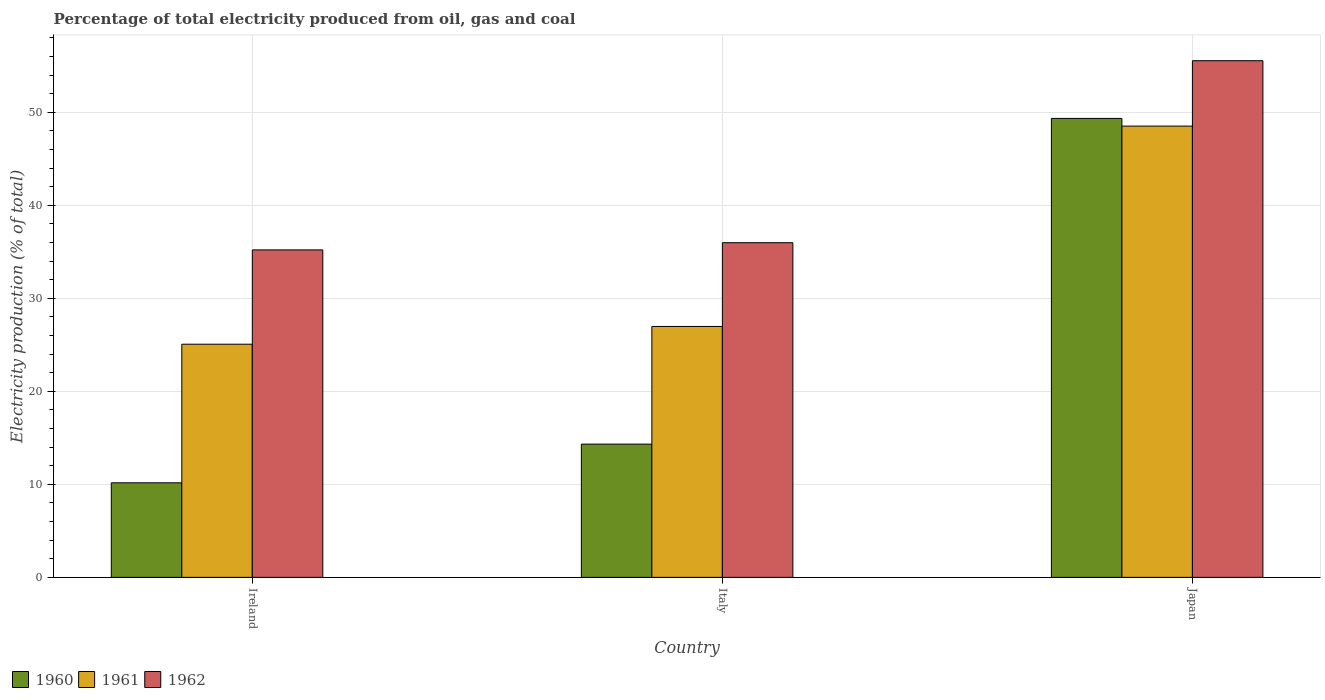How many different coloured bars are there?
Your response must be concise. 3. How many groups of bars are there?
Provide a succinct answer. 3. Are the number of bars per tick equal to the number of legend labels?
Your answer should be very brief. Yes. Are the number of bars on each tick of the X-axis equal?
Offer a very short reply. Yes. What is the label of the 2nd group of bars from the left?
Offer a terse response. Italy. What is the electricity production in in 1960 in Italy?
Your answer should be compact. 14.33. Across all countries, what is the maximum electricity production in in 1962?
Keep it short and to the point. 55.56. Across all countries, what is the minimum electricity production in in 1962?
Your response must be concise. 35.21. In which country was the electricity production in in 1960 minimum?
Your answer should be very brief. Ireland. What is the total electricity production in in 1960 in the graph?
Your response must be concise. 73.85. What is the difference between the electricity production in in 1962 in Italy and that in Japan?
Provide a short and direct response. -19.57. What is the difference between the electricity production in in 1962 in Italy and the electricity production in in 1961 in Japan?
Keep it short and to the point. -12.54. What is the average electricity production in in 1960 per country?
Offer a very short reply. 24.62. What is the difference between the electricity production in of/in 1961 and electricity production in of/in 1962 in Ireland?
Provide a succinct answer. -10.14. In how many countries, is the electricity production in in 1960 greater than 8 %?
Ensure brevity in your answer.  3. What is the ratio of the electricity production in in 1961 in Ireland to that in Japan?
Ensure brevity in your answer.  0.52. Is the difference between the electricity production in in 1961 in Italy and Japan greater than the difference between the electricity production in in 1962 in Italy and Japan?
Offer a terse response. No. What is the difference between the highest and the second highest electricity production in in 1961?
Ensure brevity in your answer.  23.45. What is the difference between the highest and the lowest electricity production in in 1962?
Provide a succinct answer. 20.34. Is it the case that in every country, the sum of the electricity production in in 1961 and electricity production in in 1960 is greater than the electricity production in in 1962?
Offer a very short reply. Yes. How many bars are there?
Offer a terse response. 9. How many countries are there in the graph?
Offer a very short reply. 3. Are the values on the major ticks of Y-axis written in scientific E-notation?
Keep it short and to the point. No. Does the graph contain any zero values?
Give a very brief answer. No. Where does the legend appear in the graph?
Offer a terse response. Bottom left. How many legend labels are there?
Give a very brief answer. 3. How are the legend labels stacked?
Give a very brief answer. Horizontal. What is the title of the graph?
Offer a terse response. Percentage of total electricity produced from oil, gas and coal. Does "2009" appear as one of the legend labels in the graph?
Offer a very short reply. No. What is the label or title of the Y-axis?
Give a very brief answer. Electricity production (% of total). What is the Electricity production (% of total) of 1960 in Ireland?
Your answer should be very brief. 10.17. What is the Electricity production (% of total) in 1961 in Ireland?
Your response must be concise. 25.07. What is the Electricity production (% of total) of 1962 in Ireland?
Keep it short and to the point. 35.21. What is the Electricity production (% of total) in 1960 in Italy?
Your answer should be compact. 14.33. What is the Electricity production (% of total) in 1961 in Italy?
Provide a short and direct response. 26.98. What is the Electricity production (% of total) in 1962 in Italy?
Provide a succinct answer. 35.99. What is the Electricity production (% of total) in 1960 in Japan?
Your answer should be very brief. 49.35. What is the Electricity production (% of total) of 1961 in Japan?
Provide a short and direct response. 48.52. What is the Electricity production (% of total) in 1962 in Japan?
Provide a short and direct response. 55.56. Across all countries, what is the maximum Electricity production (% of total) of 1960?
Make the answer very short. 49.35. Across all countries, what is the maximum Electricity production (% of total) in 1961?
Your response must be concise. 48.52. Across all countries, what is the maximum Electricity production (% of total) in 1962?
Give a very brief answer. 55.56. Across all countries, what is the minimum Electricity production (% of total) in 1960?
Your response must be concise. 10.17. Across all countries, what is the minimum Electricity production (% of total) in 1961?
Offer a terse response. 25.07. Across all countries, what is the minimum Electricity production (% of total) in 1962?
Offer a terse response. 35.21. What is the total Electricity production (% of total) of 1960 in the graph?
Provide a succinct answer. 73.85. What is the total Electricity production (% of total) of 1961 in the graph?
Your response must be concise. 100.57. What is the total Electricity production (% of total) of 1962 in the graph?
Provide a short and direct response. 126.75. What is the difference between the Electricity production (% of total) in 1960 in Ireland and that in Italy?
Provide a succinct answer. -4.16. What is the difference between the Electricity production (% of total) of 1961 in Ireland and that in Italy?
Give a very brief answer. -1.91. What is the difference between the Electricity production (% of total) of 1962 in Ireland and that in Italy?
Your answer should be compact. -0.78. What is the difference between the Electricity production (% of total) of 1960 in Ireland and that in Japan?
Your response must be concise. -39.18. What is the difference between the Electricity production (% of total) in 1961 in Ireland and that in Japan?
Keep it short and to the point. -23.45. What is the difference between the Electricity production (% of total) in 1962 in Ireland and that in Japan?
Provide a succinct answer. -20.34. What is the difference between the Electricity production (% of total) of 1960 in Italy and that in Japan?
Offer a very short reply. -35.02. What is the difference between the Electricity production (% of total) in 1961 in Italy and that in Japan?
Provide a succinct answer. -21.55. What is the difference between the Electricity production (% of total) of 1962 in Italy and that in Japan?
Your answer should be very brief. -19.57. What is the difference between the Electricity production (% of total) of 1960 in Ireland and the Electricity production (% of total) of 1961 in Italy?
Your answer should be compact. -16.81. What is the difference between the Electricity production (% of total) of 1960 in Ireland and the Electricity production (% of total) of 1962 in Italy?
Give a very brief answer. -25.82. What is the difference between the Electricity production (% of total) in 1961 in Ireland and the Electricity production (% of total) in 1962 in Italy?
Offer a very short reply. -10.92. What is the difference between the Electricity production (% of total) of 1960 in Ireland and the Electricity production (% of total) of 1961 in Japan?
Your answer should be very brief. -38.36. What is the difference between the Electricity production (% of total) of 1960 in Ireland and the Electricity production (% of total) of 1962 in Japan?
Your response must be concise. -45.39. What is the difference between the Electricity production (% of total) in 1961 in Ireland and the Electricity production (% of total) in 1962 in Japan?
Offer a terse response. -30.48. What is the difference between the Electricity production (% of total) of 1960 in Italy and the Electricity production (% of total) of 1961 in Japan?
Ensure brevity in your answer.  -34.2. What is the difference between the Electricity production (% of total) of 1960 in Italy and the Electricity production (% of total) of 1962 in Japan?
Your answer should be very brief. -41.23. What is the difference between the Electricity production (% of total) of 1961 in Italy and the Electricity production (% of total) of 1962 in Japan?
Your answer should be compact. -28.58. What is the average Electricity production (% of total) of 1960 per country?
Provide a short and direct response. 24.62. What is the average Electricity production (% of total) in 1961 per country?
Your response must be concise. 33.52. What is the average Electricity production (% of total) in 1962 per country?
Provide a short and direct response. 42.25. What is the difference between the Electricity production (% of total) of 1960 and Electricity production (% of total) of 1961 in Ireland?
Your answer should be very brief. -14.9. What is the difference between the Electricity production (% of total) in 1960 and Electricity production (% of total) in 1962 in Ireland?
Give a very brief answer. -25.04. What is the difference between the Electricity production (% of total) in 1961 and Electricity production (% of total) in 1962 in Ireland?
Offer a terse response. -10.14. What is the difference between the Electricity production (% of total) in 1960 and Electricity production (% of total) in 1961 in Italy?
Provide a short and direct response. -12.65. What is the difference between the Electricity production (% of total) in 1960 and Electricity production (% of total) in 1962 in Italy?
Provide a short and direct response. -21.66. What is the difference between the Electricity production (% of total) in 1961 and Electricity production (% of total) in 1962 in Italy?
Make the answer very short. -9.01. What is the difference between the Electricity production (% of total) in 1960 and Electricity production (% of total) in 1961 in Japan?
Offer a terse response. 0.83. What is the difference between the Electricity production (% of total) in 1960 and Electricity production (% of total) in 1962 in Japan?
Your answer should be very brief. -6.2. What is the difference between the Electricity production (% of total) of 1961 and Electricity production (% of total) of 1962 in Japan?
Give a very brief answer. -7.03. What is the ratio of the Electricity production (% of total) in 1960 in Ireland to that in Italy?
Ensure brevity in your answer.  0.71. What is the ratio of the Electricity production (% of total) of 1961 in Ireland to that in Italy?
Offer a very short reply. 0.93. What is the ratio of the Electricity production (% of total) in 1962 in Ireland to that in Italy?
Give a very brief answer. 0.98. What is the ratio of the Electricity production (% of total) of 1960 in Ireland to that in Japan?
Ensure brevity in your answer.  0.21. What is the ratio of the Electricity production (% of total) of 1961 in Ireland to that in Japan?
Provide a succinct answer. 0.52. What is the ratio of the Electricity production (% of total) of 1962 in Ireland to that in Japan?
Keep it short and to the point. 0.63. What is the ratio of the Electricity production (% of total) of 1960 in Italy to that in Japan?
Your response must be concise. 0.29. What is the ratio of the Electricity production (% of total) in 1961 in Italy to that in Japan?
Offer a terse response. 0.56. What is the ratio of the Electricity production (% of total) of 1962 in Italy to that in Japan?
Your answer should be very brief. 0.65. What is the difference between the highest and the second highest Electricity production (% of total) in 1960?
Keep it short and to the point. 35.02. What is the difference between the highest and the second highest Electricity production (% of total) in 1961?
Provide a short and direct response. 21.55. What is the difference between the highest and the second highest Electricity production (% of total) of 1962?
Your response must be concise. 19.57. What is the difference between the highest and the lowest Electricity production (% of total) of 1960?
Your answer should be very brief. 39.18. What is the difference between the highest and the lowest Electricity production (% of total) in 1961?
Provide a short and direct response. 23.45. What is the difference between the highest and the lowest Electricity production (% of total) in 1962?
Your answer should be compact. 20.34. 